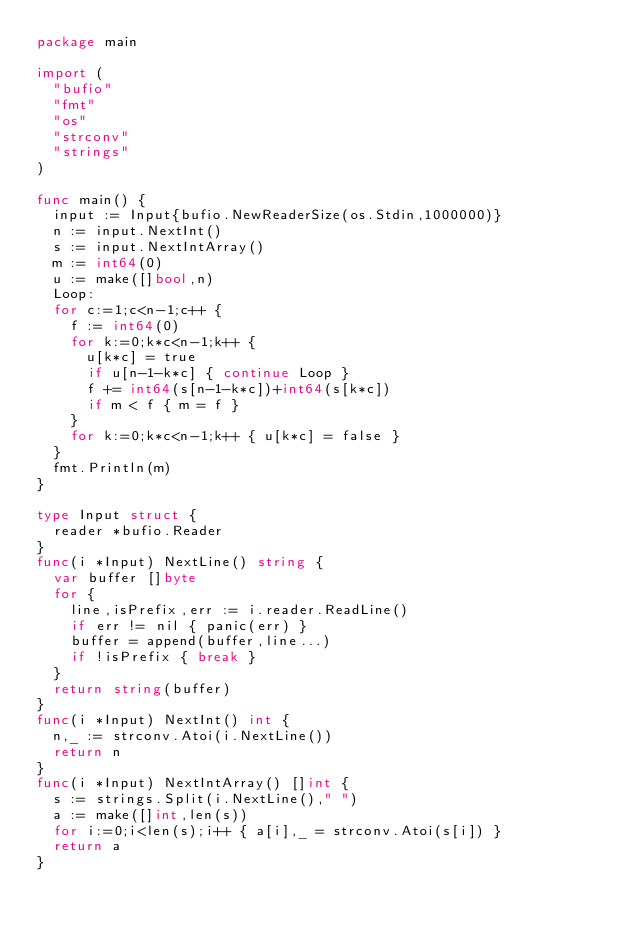Convert code to text. <code><loc_0><loc_0><loc_500><loc_500><_Go_>package main

import (
  "bufio"
  "fmt"
  "os"
  "strconv"
  "strings"
)

func main() {
  input := Input{bufio.NewReaderSize(os.Stdin,1000000)}
  n := input.NextInt()
  s := input.NextIntArray()
  m := int64(0)
  u := make([]bool,n)
  Loop:
  for c:=1;c<n-1;c++ {
    f := int64(0)
    for k:=0;k*c<n-1;k++ {
      u[k*c] = true
      if u[n-1-k*c] { continue Loop }
      f += int64(s[n-1-k*c])+int64(s[k*c])
      if m < f { m = f }
    }
    for k:=0;k*c<n-1;k++ { u[k*c] = false }
  }
  fmt.Println(m)
}

type Input struct {
  reader *bufio.Reader
}
func(i *Input) NextLine() string {
  var buffer []byte
  for {
    line,isPrefix,err := i.reader.ReadLine()
    if err != nil { panic(err) }
    buffer = append(buffer,line...)
    if !isPrefix { break }
  }
  return string(buffer)
}
func(i *Input) NextInt() int {
  n,_ := strconv.Atoi(i.NextLine())
  return n
}
func(i *Input) NextIntArray() []int {
  s := strings.Split(i.NextLine()," ")
  a := make([]int,len(s))
  for i:=0;i<len(s);i++ { a[i],_ = strconv.Atoi(s[i]) }
  return a
}</code> 